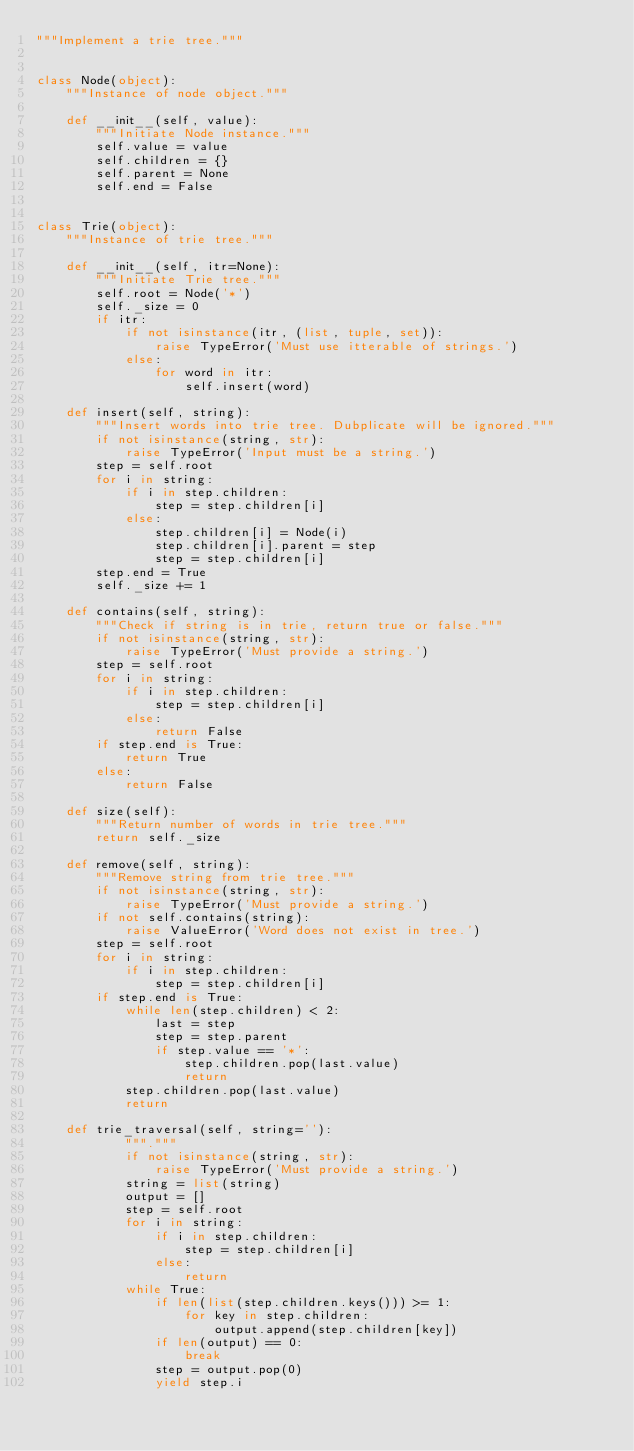Convert code to text. <code><loc_0><loc_0><loc_500><loc_500><_Python_>"""Implement a trie tree."""


class Node(object):
    """Instance of node object."""

    def __init__(self, value):
        """Initiate Node instance."""
        self.value = value
        self.children = {}
        self.parent = None
        self.end = False


class Trie(object):
    """Instance of trie tree."""

    def __init__(self, itr=None):
        """Initiate Trie tree."""
        self.root = Node('*')
        self._size = 0
        if itr:
            if not isinstance(itr, (list, tuple, set)):
                raise TypeError('Must use itterable of strings.')
            else:
                for word in itr:
                    self.insert(word)

    def insert(self, string):
        """Insert words into trie tree. Dubplicate will be ignored."""
        if not isinstance(string, str):
            raise TypeError('Input must be a string.')
        step = self.root
        for i in string:
            if i in step.children:
                step = step.children[i]
            else:
                step.children[i] = Node(i)
                step.children[i].parent = step
                step = step.children[i]
        step.end = True
        self._size += 1

    def contains(self, string):
        """Check if string is in trie, return true or false."""
        if not isinstance(string, str):
            raise TypeError('Must provide a string.')
        step = self.root
        for i in string:
            if i in step.children:
                step = step.children[i]
            else:
                return False
        if step.end is True:
            return True
        else:
            return False

    def size(self):
        """Return number of words in trie tree."""
        return self._size

    def remove(self, string):
        """Remove string from trie tree."""
        if not isinstance(string, str):
            raise TypeError('Must provide a string.')
        if not self.contains(string):
            raise ValueError('Word does not exist in tree.')
        step = self.root
        for i in string:
            if i in step.children:
                step = step.children[i]
        if step.end is True:
            while len(step.children) < 2:
                last = step
                step = step.parent
                if step.value == '*':
                    step.children.pop(last.value)
                    return
            step.children.pop(last.value)
            return

    def trie_traversal(self, string=''):
            """."""
            if not isinstance(string, str):
                raise TypeError('Must provide a string.')
            string = list(string)
            output = []
            step = self.root
            for i in string:
                if i in step.children:
                    step = step.children[i]
                else:
                    return
            while True:
                if len(list(step.children.keys())) >= 1:
                    for key in step.children:
                        output.append(step.children[key])
                if len(output) == 0:
                    break
                step = output.pop(0)
                yield step.i
</code> 